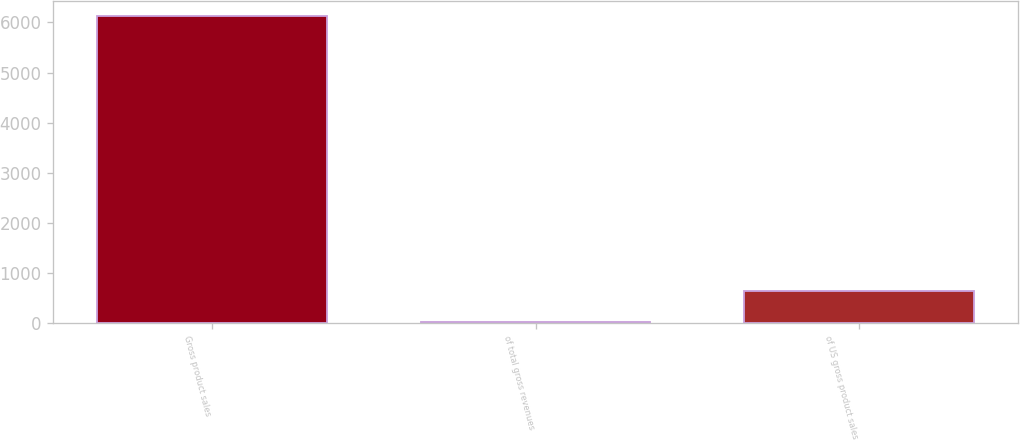Convert chart. <chart><loc_0><loc_0><loc_500><loc_500><bar_chart><fcel>Gross product sales<fcel>of total gross revenues<fcel>of US gross product sales<nl><fcel>6124<fcel>31<fcel>640.3<nl></chart> 